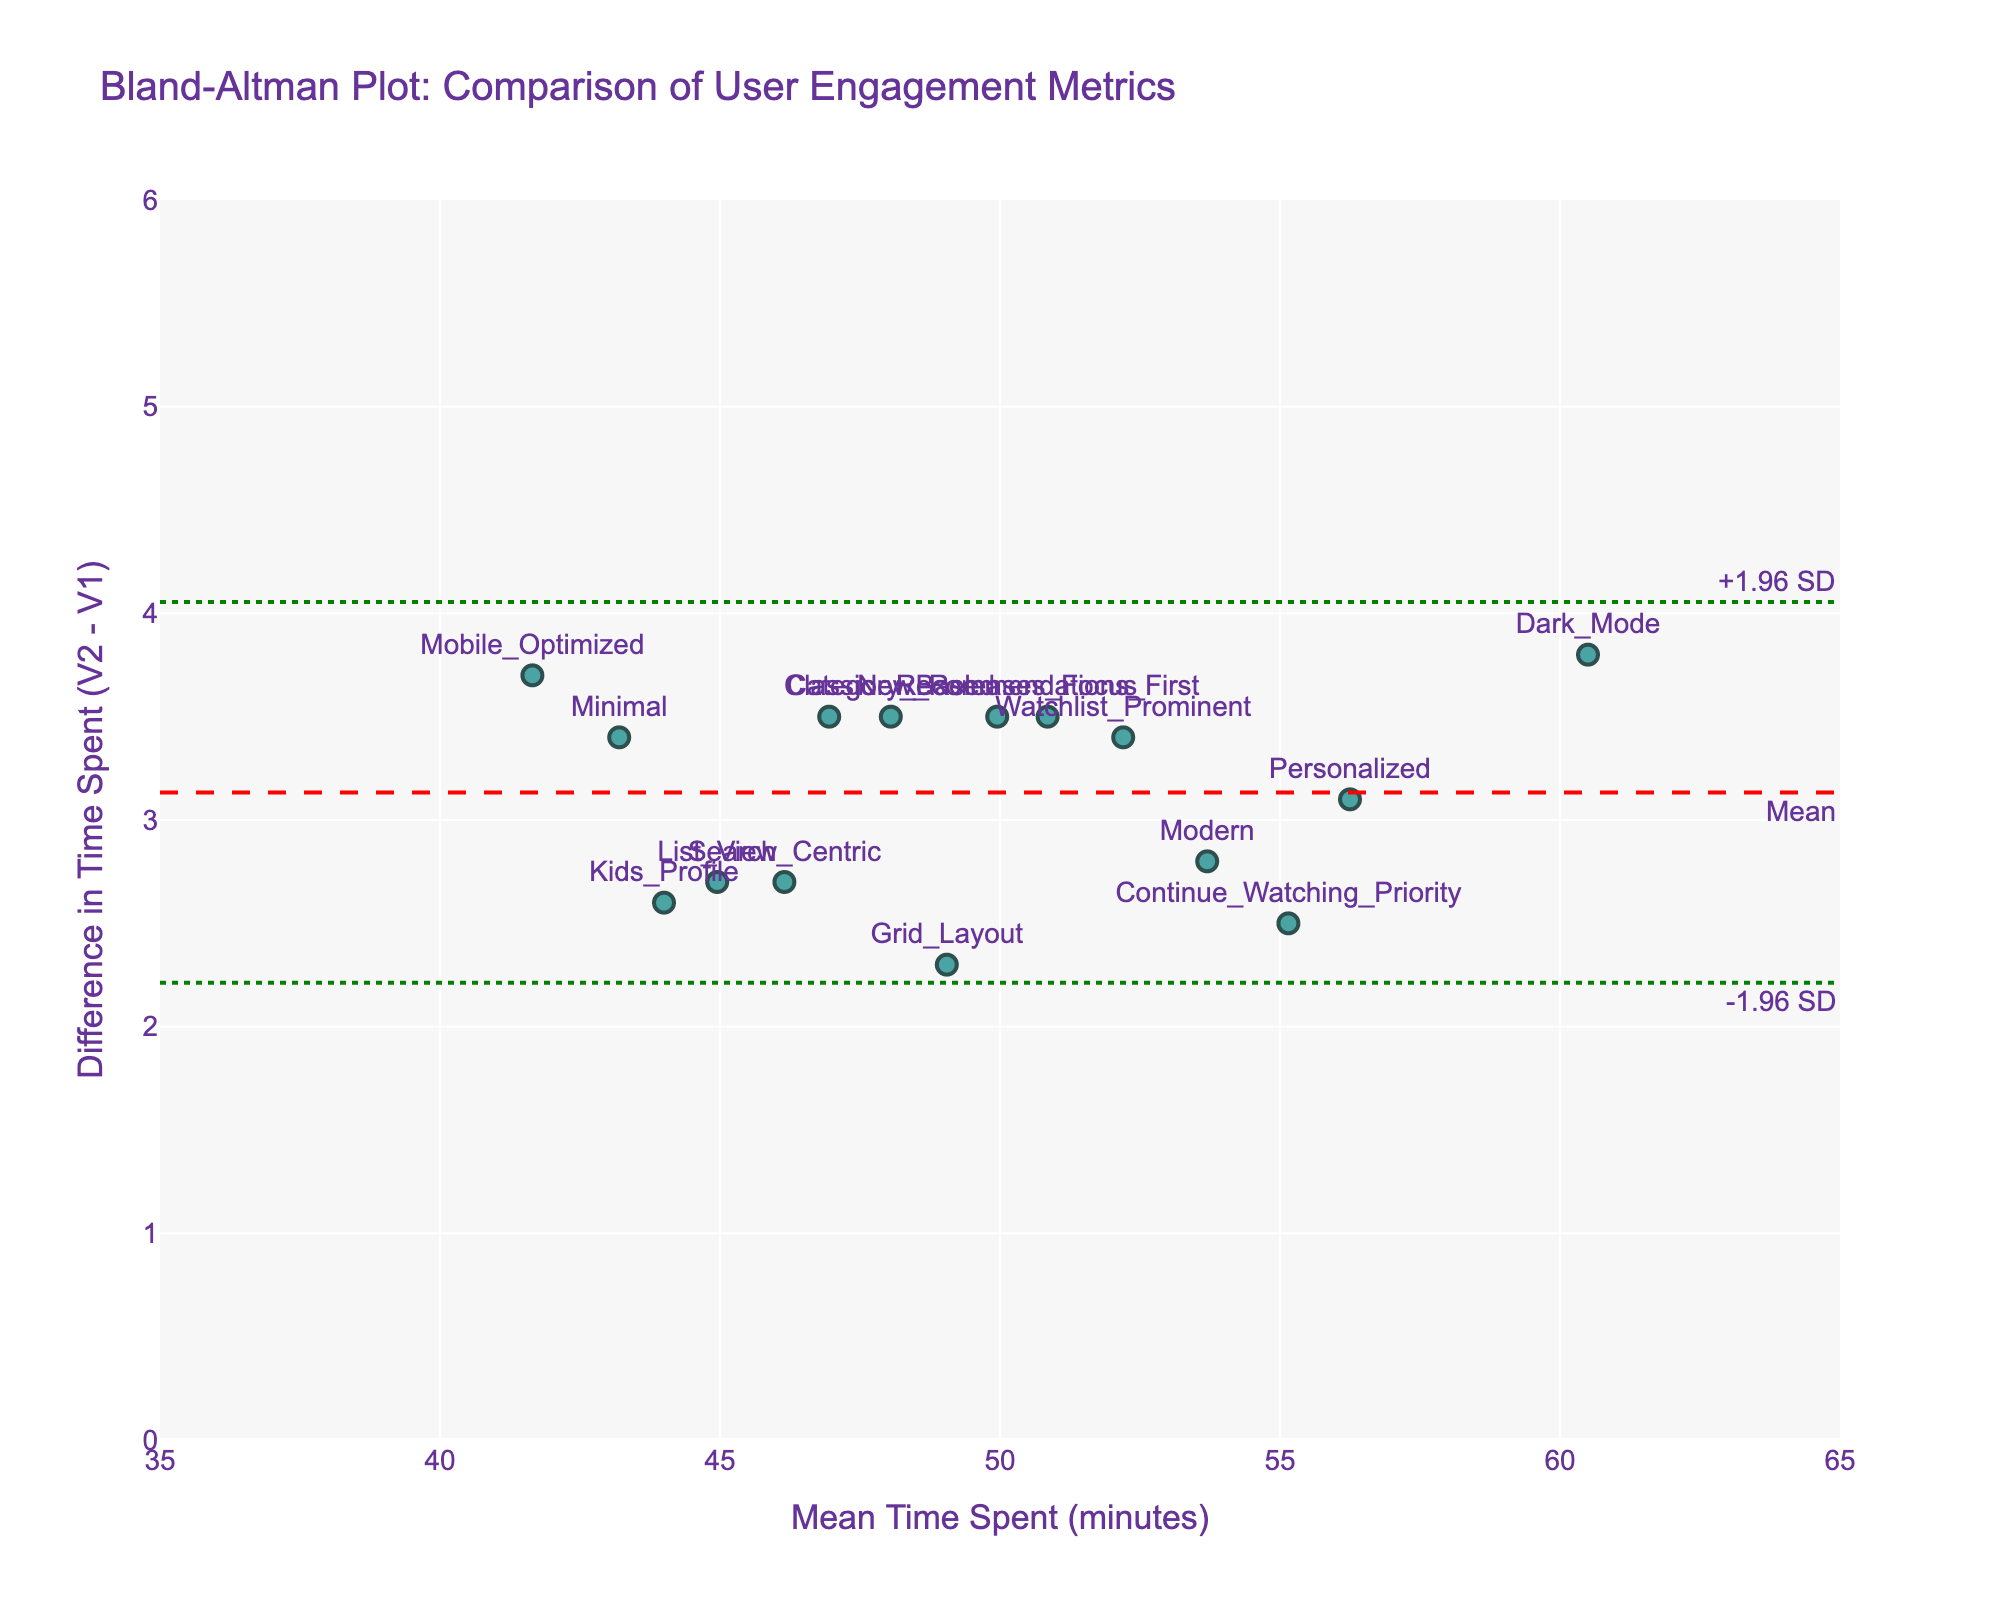What is the title of the plot? The title of the plot is typically provided at the top of the figure. In this case, it reads "Bland-Altman Plot: Comparison of User Engagement Metrics".
Answer: Bland-Altman Plot: Comparison of User Engagement Metrics What do the x-axis and y-axis represent? The x-axis represents the 'Mean Time Spent (minutes)' and the y-axis represents the 'Difference in Time Spent (V2 - V1)'. This is typically denoted by the axis labels.
Answer: Mean Time Spent (minutes) and Difference in Time Spent (V2 - V1) How many data points are plotted in the figure? Each marker on the plot represents a data point. By counting them, you can determine there are 15 data points corresponding to the different UI elements listed in the data.
Answer: 15 What color represents the data points in the figure? The data points are colored in 'rgba(0, 128, 128, 0.7)', which is a shade of teal. This can be identified by looking at the plot.
Answer: Teal What is the mean difference in time spent between the two UI versions? The mean difference is represented by the red dashed line, which is annotated with "Mean". According to the plot, this line is positioned at around 3 minutes.
Answer: 3 minutes What are the upper and lower limits of agreement for the difference in time spent? The limits of agreement are denoted by the green dotted lines. The upper limit is labeled "+1.96 SD" and the lower limit is labeled "-1.96 SD". These lines are positioned at approximately 4.9 minutes and 1.1 minutes, respectively.
Answer: 4.9 minutes and 1.1 minutes Which UI version has the largest positive difference in time spent on the platform between V2 and V1? To find the largest positive difference, look for the data point that is highest on the y-axis. The 'Dark_Mode' UI version appears to have the highest positive difference.
Answer: Dark_Mode Which UI version has the mean time spent closest to the center of the x-axis range? The center of the x-axis range (35 to 65) is around 50 minutes. By identifying the data point closest to this value on the x-axis, the 'Recommendations_First' UI version comes closest.
Answer: Recommendations_First Are there any UI versions with time spent differences outside the limits of agreement? Limits of agreement are between 1.1 and 4.9 minutes. All data points appear within this range, so there are no versions outside the limits.
Answer: No Is there a general trend between the mean time spent on the platform and the difference in time spent? By observing the dispersion of data points, you can see that differences are fairly evenly spread across the x-axis, indicating little to no general trend or correlation between the mean time spent and the difference in time spent.
Answer: No general trend 